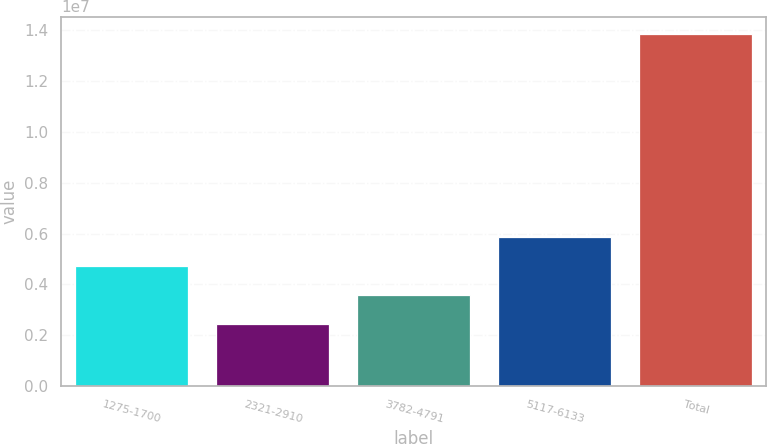<chart> <loc_0><loc_0><loc_500><loc_500><bar_chart><fcel>1275-1700<fcel>2321-2910<fcel>3782-4791<fcel>5117-6133<fcel>Total<nl><fcel>4.72328e+06<fcel>2.44367e+06<fcel>3.58348e+06<fcel>5.86309e+06<fcel>1.38417e+07<nl></chart> 